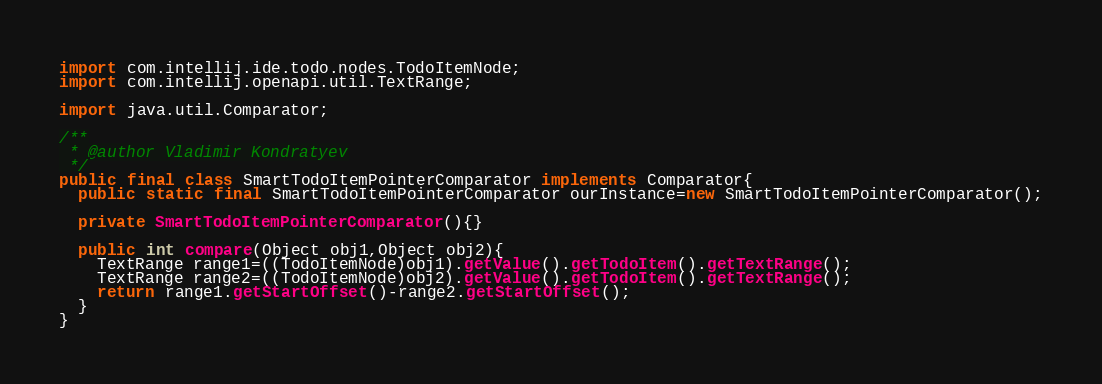<code> <loc_0><loc_0><loc_500><loc_500><_Java_>import com.intellij.ide.todo.nodes.TodoItemNode;
import com.intellij.openapi.util.TextRange;

import java.util.Comparator;

/**
 * @author Vladimir Kondratyev
 */
public final class SmartTodoItemPointerComparator implements Comparator{
  public static final SmartTodoItemPointerComparator ourInstance=new SmartTodoItemPointerComparator();

  private SmartTodoItemPointerComparator(){}

  public int compare(Object obj1,Object obj2){
    TextRange range1=((TodoItemNode)obj1).getValue().getTodoItem().getTextRange();
    TextRange range2=((TodoItemNode)obj2).getValue().getTodoItem().getTextRange();
    return range1.getStartOffset()-range2.getStartOffset();
  }
}
</code> 